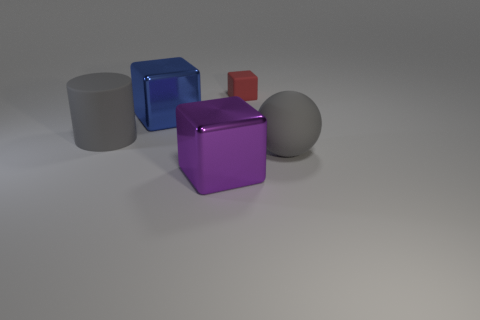There is a big object that is the same color as the big matte ball; what material is it?
Offer a terse response. Rubber. What number of other objects are the same shape as the tiny red object?
Provide a succinct answer. 2. Is the material of the gray object in front of the big matte cylinder the same as the small red object?
Provide a short and direct response. Yes. Is the number of blue metal things on the right side of the blue metallic object the same as the number of large matte things that are in front of the large purple cube?
Keep it short and to the point. Yes. There is a shiny block behind the large purple metal block; what is its size?
Give a very brief answer. Large. Is there another tiny red cube that has the same material as the red cube?
Your answer should be very brief. No. There is a metal object on the left side of the purple block; does it have the same color as the large rubber cylinder?
Provide a short and direct response. No. Are there an equal number of purple metal blocks that are behind the big purple metallic cube and big brown rubber balls?
Provide a short and direct response. Yes. Are there any spheres of the same color as the large rubber cylinder?
Your response must be concise. Yes. Do the red thing and the purple shiny object have the same size?
Provide a short and direct response. No. 